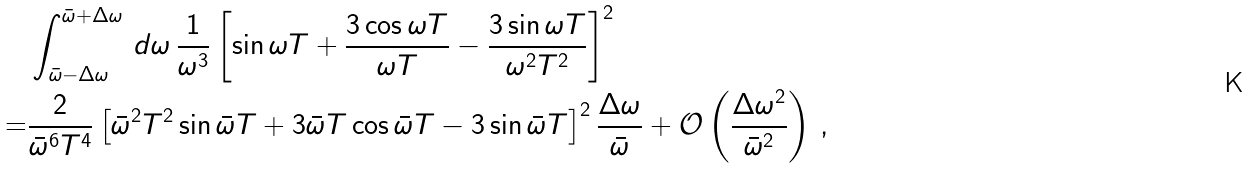Convert formula to latex. <formula><loc_0><loc_0><loc_500><loc_500>& \int _ { \bar { \omega } - \Delta \omega } ^ { \bar { \omega } + \Delta \omega } \, d \omega \, \frac { 1 } { \omega ^ { 3 } } \left [ \sin \omega T + \frac { 3 \cos \omega T } { \omega T } - \frac { 3 \sin \omega T } { \omega ^ { 2 } T ^ { 2 } } \right ] ^ { 2 } \\ = & \frac { 2 } { \bar { \omega } ^ { 6 } T ^ { 4 } } \left [ \bar { \omega } ^ { 2 } T ^ { 2 } \sin \bar { \omega } T + 3 \bar { \omega } T \cos \bar { \omega } T - 3 \sin \bar { \omega } T \right ] ^ { 2 } \frac { \Delta \omega } { \bar { \omega } } + \mathcal { O } \left ( \frac { \Delta \omega ^ { 2 } } { \bar { \omega } ^ { 2 } } \right ) \, ,</formula> 